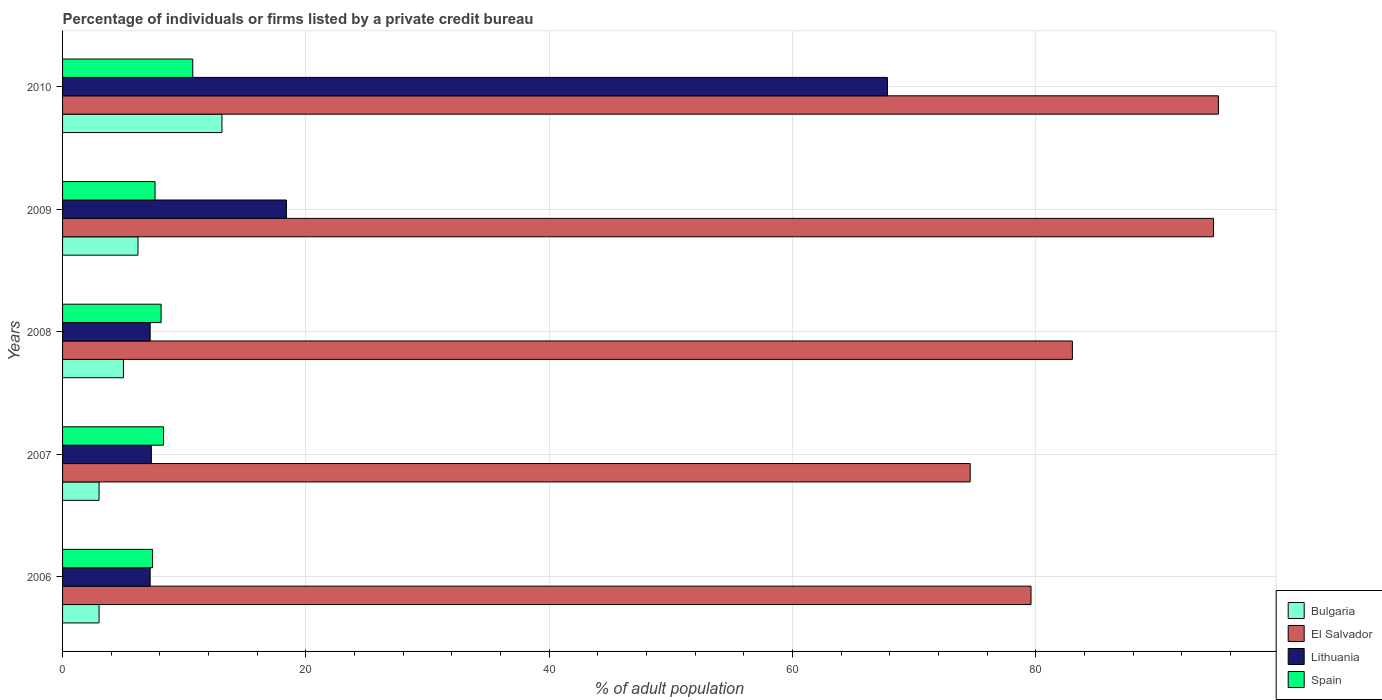How many groups of bars are there?
Offer a very short reply. 5. Are the number of bars per tick equal to the number of legend labels?
Ensure brevity in your answer.  Yes. Are the number of bars on each tick of the Y-axis equal?
Keep it short and to the point. Yes. What is the label of the 3rd group of bars from the top?
Your answer should be very brief. 2008. What is the percentage of population listed by a private credit bureau in Spain in 2010?
Your answer should be compact. 10.7. Across all years, what is the maximum percentage of population listed by a private credit bureau in Spain?
Offer a terse response. 10.7. In which year was the percentage of population listed by a private credit bureau in Lithuania maximum?
Your response must be concise. 2010. In which year was the percentage of population listed by a private credit bureau in Lithuania minimum?
Provide a short and direct response. 2006. What is the total percentage of population listed by a private credit bureau in El Salvador in the graph?
Give a very brief answer. 426.8. What is the difference between the percentage of population listed by a private credit bureau in Bulgaria in 2008 and the percentage of population listed by a private credit bureau in El Salvador in 2007?
Give a very brief answer. -69.6. What is the average percentage of population listed by a private credit bureau in Bulgaria per year?
Keep it short and to the point. 6.06. In the year 2007, what is the difference between the percentage of population listed by a private credit bureau in Spain and percentage of population listed by a private credit bureau in Lithuania?
Provide a short and direct response. 1. What is the ratio of the percentage of population listed by a private credit bureau in Lithuania in 2009 to that in 2010?
Offer a terse response. 0.27. Is the percentage of population listed by a private credit bureau in Bulgaria in 2006 less than that in 2009?
Offer a terse response. Yes. What is the difference between the highest and the second highest percentage of population listed by a private credit bureau in El Salvador?
Provide a short and direct response. 0.4. What is the difference between the highest and the lowest percentage of population listed by a private credit bureau in El Salvador?
Provide a succinct answer. 20.4. How many bars are there?
Ensure brevity in your answer.  20. Does the graph contain any zero values?
Give a very brief answer. No. Does the graph contain grids?
Your response must be concise. Yes. How many legend labels are there?
Keep it short and to the point. 4. What is the title of the graph?
Provide a short and direct response. Percentage of individuals or firms listed by a private credit bureau. Does "Korea (Democratic)" appear as one of the legend labels in the graph?
Keep it short and to the point. No. What is the label or title of the X-axis?
Provide a short and direct response. % of adult population. What is the label or title of the Y-axis?
Make the answer very short. Years. What is the % of adult population of Bulgaria in 2006?
Your answer should be very brief. 3. What is the % of adult population of El Salvador in 2006?
Provide a short and direct response. 79.6. What is the % of adult population in Lithuania in 2006?
Your response must be concise. 7.2. What is the % of adult population of Bulgaria in 2007?
Offer a terse response. 3. What is the % of adult population of El Salvador in 2007?
Provide a short and direct response. 74.6. What is the % of adult population in Spain in 2008?
Give a very brief answer. 8.1. What is the % of adult population of El Salvador in 2009?
Ensure brevity in your answer.  94.6. What is the % of adult population of Spain in 2009?
Ensure brevity in your answer.  7.6. What is the % of adult population of Bulgaria in 2010?
Your response must be concise. 13.1. What is the % of adult population of El Salvador in 2010?
Ensure brevity in your answer.  95. What is the % of adult population in Lithuania in 2010?
Offer a terse response. 67.8. Across all years, what is the maximum % of adult population in El Salvador?
Keep it short and to the point. 95. Across all years, what is the maximum % of adult population in Lithuania?
Provide a succinct answer. 67.8. Across all years, what is the minimum % of adult population of El Salvador?
Make the answer very short. 74.6. What is the total % of adult population in Bulgaria in the graph?
Make the answer very short. 30.3. What is the total % of adult population of El Salvador in the graph?
Your response must be concise. 426.8. What is the total % of adult population of Lithuania in the graph?
Your response must be concise. 107.9. What is the total % of adult population of Spain in the graph?
Your response must be concise. 42.1. What is the difference between the % of adult population of Bulgaria in 2006 and that in 2007?
Provide a short and direct response. 0. What is the difference between the % of adult population in El Salvador in 2006 and that in 2007?
Your answer should be very brief. 5. What is the difference between the % of adult population in El Salvador in 2006 and that in 2008?
Make the answer very short. -3.4. What is the difference between the % of adult population of Lithuania in 2006 and that in 2008?
Make the answer very short. 0. What is the difference between the % of adult population of Bulgaria in 2006 and that in 2009?
Make the answer very short. -3.2. What is the difference between the % of adult population of El Salvador in 2006 and that in 2009?
Provide a short and direct response. -15. What is the difference between the % of adult population in El Salvador in 2006 and that in 2010?
Make the answer very short. -15.4. What is the difference between the % of adult population in Lithuania in 2006 and that in 2010?
Ensure brevity in your answer.  -60.6. What is the difference between the % of adult population in Bulgaria in 2007 and that in 2008?
Your response must be concise. -2. What is the difference between the % of adult population of El Salvador in 2007 and that in 2009?
Your answer should be compact. -20. What is the difference between the % of adult population of El Salvador in 2007 and that in 2010?
Offer a very short reply. -20.4. What is the difference between the % of adult population of Lithuania in 2007 and that in 2010?
Your response must be concise. -60.5. What is the difference between the % of adult population of Bulgaria in 2008 and that in 2009?
Your response must be concise. -1.2. What is the difference between the % of adult population in Lithuania in 2008 and that in 2009?
Offer a very short reply. -11.2. What is the difference between the % of adult population of Lithuania in 2008 and that in 2010?
Your response must be concise. -60.6. What is the difference between the % of adult population in Bulgaria in 2009 and that in 2010?
Your answer should be very brief. -6.9. What is the difference between the % of adult population of El Salvador in 2009 and that in 2010?
Give a very brief answer. -0.4. What is the difference between the % of adult population of Lithuania in 2009 and that in 2010?
Your answer should be very brief. -49.4. What is the difference between the % of adult population of Bulgaria in 2006 and the % of adult population of El Salvador in 2007?
Your answer should be very brief. -71.6. What is the difference between the % of adult population in Bulgaria in 2006 and the % of adult population in Spain in 2007?
Ensure brevity in your answer.  -5.3. What is the difference between the % of adult population in El Salvador in 2006 and the % of adult population in Lithuania in 2007?
Give a very brief answer. 72.3. What is the difference between the % of adult population of El Salvador in 2006 and the % of adult population of Spain in 2007?
Give a very brief answer. 71.3. What is the difference between the % of adult population in Lithuania in 2006 and the % of adult population in Spain in 2007?
Offer a very short reply. -1.1. What is the difference between the % of adult population of Bulgaria in 2006 and the % of adult population of El Salvador in 2008?
Ensure brevity in your answer.  -80. What is the difference between the % of adult population in Bulgaria in 2006 and the % of adult population in Lithuania in 2008?
Provide a short and direct response. -4.2. What is the difference between the % of adult population of Bulgaria in 2006 and the % of adult population of Spain in 2008?
Keep it short and to the point. -5.1. What is the difference between the % of adult population in El Salvador in 2006 and the % of adult population in Lithuania in 2008?
Your answer should be compact. 72.4. What is the difference between the % of adult population in El Salvador in 2006 and the % of adult population in Spain in 2008?
Your answer should be very brief. 71.5. What is the difference between the % of adult population of Bulgaria in 2006 and the % of adult population of El Salvador in 2009?
Offer a terse response. -91.6. What is the difference between the % of adult population in Bulgaria in 2006 and the % of adult population in Lithuania in 2009?
Your answer should be compact. -15.4. What is the difference between the % of adult population in El Salvador in 2006 and the % of adult population in Lithuania in 2009?
Ensure brevity in your answer.  61.2. What is the difference between the % of adult population of El Salvador in 2006 and the % of adult population of Spain in 2009?
Your response must be concise. 72. What is the difference between the % of adult population in Lithuania in 2006 and the % of adult population in Spain in 2009?
Your response must be concise. -0.4. What is the difference between the % of adult population in Bulgaria in 2006 and the % of adult population in El Salvador in 2010?
Give a very brief answer. -92. What is the difference between the % of adult population of Bulgaria in 2006 and the % of adult population of Lithuania in 2010?
Your response must be concise. -64.8. What is the difference between the % of adult population of El Salvador in 2006 and the % of adult population of Spain in 2010?
Keep it short and to the point. 68.9. What is the difference between the % of adult population in Lithuania in 2006 and the % of adult population in Spain in 2010?
Make the answer very short. -3.5. What is the difference between the % of adult population in Bulgaria in 2007 and the % of adult population in El Salvador in 2008?
Provide a short and direct response. -80. What is the difference between the % of adult population of El Salvador in 2007 and the % of adult population of Lithuania in 2008?
Ensure brevity in your answer.  67.4. What is the difference between the % of adult population of El Salvador in 2007 and the % of adult population of Spain in 2008?
Your answer should be very brief. 66.5. What is the difference between the % of adult population in Lithuania in 2007 and the % of adult population in Spain in 2008?
Your response must be concise. -0.8. What is the difference between the % of adult population of Bulgaria in 2007 and the % of adult population of El Salvador in 2009?
Your answer should be compact. -91.6. What is the difference between the % of adult population of Bulgaria in 2007 and the % of adult population of Lithuania in 2009?
Make the answer very short. -15.4. What is the difference between the % of adult population of Bulgaria in 2007 and the % of adult population of Spain in 2009?
Your response must be concise. -4.6. What is the difference between the % of adult population in El Salvador in 2007 and the % of adult population in Lithuania in 2009?
Offer a very short reply. 56.2. What is the difference between the % of adult population of Bulgaria in 2007 and the % of adult population of El Salvador in 2010?
Give a very brief answer. -92. What is the difference between the % of adult population of Bulgaria in 2007 and the % of adult population of Lithuania in 2010?
Provide a short and direct response. -64.8. What is the difference between the % of adult population in Bulgaria in 2007 and the % of adult population in Spain in 2010?
Offer a very short reply. -7.7. What is the difference between the % of adult population in El Salvador in 2007 and the % of adult population in Spain in 2010?
Make the answer very short. 63.9. What is the difference between the % of adult population of Bulgaria in 2008 and the % of adult population of El Salvador in 2009?
Provide a succinct answer. -89.6. What is the difference between the % of adult population of Bulgaria in 2008 and the % of adult population of Lithuania in 2009?
Ensure brevity in your answer.  -13.4. What is the difference between the % of adult population in El Salvador in 2008 and the % of adult population in Lithuania in 2009?
Keep it short and to the point. 64.6. What is the difference between the % of adult population of El Salvador in 2008 and the % of adult population of Spain in 2009?
Give a very brief answer. 75.4. What is the difference between the % of adult population of Bulgaria in 2008 and the % of adult population of El Salvador in 2010?
Make the answer very short. -90. What is the difference between the % of adult population in Bulgaria in 2008 and the % of adult population in Lithuania in 2010?
Your response must be concise. -62.8. What is the difference between the % of adult population in Bulgaria in 2008 and the % of adult population in Spain in 2010?
Give a very brief answer. -5.7. What is the difference between the % of adult population in El Salvador in 2008 and the % of adult population in Lithuania in 2010?
Provide a succinct answer. 15.2. What is the difference between the % of adult population of El Salvador in 2008 and the % of adult population of Spain in 2010?
Give a very brief answer. 72.3. What is the difference between the % of adult population in Lithuania in 2008 and the % of adult population in Spain in 2010?
Offer a terse response. -3.5. What is the difference between the % of adult population in Bulgaria in 2009 and the % of adult population in El Salvador in 2010?
Keep it short and to the point. -88.8. What is the difference between the % of adult population in Bulgaria in 2009 and the % of adult population in Lithuania in 2010?
Keep it short and to the point. -61.6. What is the difference between the % of adult population in Bulgaria in 2009 and the % of adult population in Spain in 2010?
Give a very brief answer. -4.5. What is the difference between the % of adult population in El Salvador in 2009 and the % of adult population in Lithuania in 2010?
Give a very brief answer. 26.8. What is the difference between the % of adult population of El Salvador in 2009 and the % of adult population of Spain in 2010?
Your answer should be very brief. 83.9. What is the difference between the % of adult population in Lithuania in 2009 and the % of adult population in Spain in 2010?
Make the answer very short. 7.7. What is the average % of adult population of Bulgaria per year?
Your answer should be compact. 6.06. What is the average % of adult population of El Salvador per year?
Provide a short and direct response. 85.36. What is the average % of adult population in Lithuania per year?
Your answer should be compact. 21.58. What is the average % of adult population of Spain per year?
Your answer should be very brief. 8.42. In the year 2006, what is the difference between the % of adult population in Bulgaria and % of adult population in El Salvador?
Offer a terse response. -76.6. In the year 2006, what is the difference between the % of adult population of Bulgaria and % of adult population of Spain?
Make the answer very short. -4.4. In the year 2006, what is the difference between the % of adult population in El Salvador and % of adult population in Lithuania?
Offer a terse response. 72.4. In the year 2006, what is the difference between the % of adult population of El Salvador and % of adult population of Spain?
Your answer should be very brief. 72.2. In the year 2006, what is the difference between the % of adult population of Lithuania and % of adult population of Spain?
Give a very brief answer. -0.2. In the year 2007, what is the difference between the % of adult population of Bulgaria and % of adult population of El Salvador?
Make the answer very short. -71.6. In the year 2007, what is the difference between the % of adult population in Bulgaria and % of adult population in Lithuania?
Make the answer very short. -4.3. In the year 2007, what is the difference between the % of adult population of Bulgaria and % of adult population of Spain?
Provide a short and direct response. -5.3. In the year 2007, what is the difference between the % of adult population in El Salvador and % of adult population in Lithuania?
Offer a very short reply. 67.3. In the year 2007, what is the difference between the % of adult population of El Salvador and % of adult population of Spain?
Offer a very short reply. 66.3. In the year 2007, what is the difference between the % of adult population of Lithuania and % of adult population of Spain?
Keep it short and to the point. -1. In the year 2008, what is the difference between the % of adult population in Bulgaria and % of adult population in El Salvador?
Provide a succinct answer. -78. In the year 2008, what is the difference between the % of adult population in Bulgaria and % of adult population in Lithuania?
Ensure brevity in your answer.  -2.2. In the year 2008, what is the difference between the % of adult population of El Salvador and % of adult population of Lithuania?
Your answer should be very brief. 75.8. In the year 2008, what is the difference between the % of adult population of El Salvador and % of adult population of Spain?
Ensure brevity in your answer.  74.9. In the year 2009, what is the difference between the % of adult population in Bulgaria and % of adult population in El Salvador?
Ensure brevity in your answer.  -88.4. In the year 2009, what is the difference between the % of adult population in Bulgaria and % of adult population in Spain?
Provide a short and direct response. -1.4. In the year 2009, what is the difference between the % of adult population in El Salvador and % of adult population in Lithuania?
Keep it short and to the point. 76.2. In the year 2009, what is the difference between the % of adult population of Lithuania and % of adult population of Spain?
Give a very brief answer. 10.8. In the year 2010, what is the difference between the % of adult population of Bulgaria and % of adult population of El Salvador?
Ensure brevity in your answer.  -81.9. In the year 2010, what is the difference between the % of adult population in Bulgaria and % of adult population in Lithuania?
Make the answer very short. -54.7. In the year 2010, what is the difference between the % of adult population of El Salvador and % of adult population of Lithuania?
Provide a short and direct response. 27.2. In the year 2010, what is the difference between the % of adult population of El Salvador and % of adult population of Spain?
Provide a succinct answer. 84.3. In the year 2010, what is the difference between the % of adult population in Lithuania and % of adult population in Spain?
Ensure brevity in your answer.  57.1. What is the ratio of the % of adult population of El Salvador in 2006 to that in 2007?
Give a very brief answer. 1.07. What is the ratio of the % of adult population of Lithuania in 2006 to that in 2007?
Your answer should be very brief. 0.99. What is the ratio of the % of adult population of Spain in 2006 to that in 2007?
Provide a short and direct response. 0.89. What is the ratio of the % of adult population of Bulgaria in 2006 to that in 2008?
Keep it short and to the point. 0.6. What is the ratio of the % of adult population of Spain in 2006 to that in 2008?
Provide a short and direct response. 0.91. What is the ratio of the % of adult population of Bulgaria in 2006 to that in 2009?
Provide a succinct answer. 0.48. What is the ratio of the % of adult population of El Salvador in 2006 to that in 2009?
Your answer should be compact. 0.84. What is the ratio of the % of adult population of Lithuania in 2006 to that in 2009?
Offer a terse response. 0.39. What is the ratio of the % of adult population of Spain in 2006 to that in 2009?
Give a very brief answer. 0.97. What is the ratio of the % of adult population of Bulgaria in 2006 to that in 2010?
Provide a succinct answer. 0.23. What is the ratio of the % of adult population of El Salvador in 2006 to that in 2010?
Ensure brevity in your answer.  0.84. What is the ratio of the % of adult population of Lithuania in 2006 to that in 2010?
Provide a short and direct response. 0.11. What is the ratio of the % of adult population of Spain in 2006 to that in 2010?
Offer a terse response. 0.69. What is the ratio of the % of adult population in El Salvador in 2007 to that in 2008?
Make the answer very short. 0.9. What is the ratio of the % of adult population of Lithuania in 2007 to that in 2008?
Ensure brevity in your answer.  1.01. What is the ratio of the % of adult population in Spain in 2007 to that in 2008?
Offer a terse response. 1.02. What is the ratio of the % of adult population of Bulgaria in 2007 to that in 2009?
Provide a succinct answer. 0.48. What is the ratio of the % of adult population of El Salvador in 2007 to that in 2009?
Provide a short and direct response. 0.79. What is the ratio of the % of adult population of Lithuania in 2007 to that in 2009?
Make the answer very short. 0.4. What is the ratio of the % of adult population of Spain in 2007 to that in 2009?
Make the answer very short. 1.09. What is the ratio of the % of adult population in Bulgaria in 2007 to that in 2010?
Your response must be concise. 0.23. What is the ratio of the % of adult population of El Salvador in 2007 to that in 2010?
Ensure brevity in your answer.  0.79. What is the ratio of the % of adult population of Lithuania in 2007 to that in 2010?
Keep it short and to the point. 0.11. What is the ratio of the % of adult population in Spain in 2007 to that in 2010?
Provide a succinct answer. 0.78. What is the ratio of the % of adult population in Bulgaria in 2008 to that in 2009?
Offer a terse response. 0.81. What is the ratio of the % of adult population in El Salvador in 2008 to that in 2009?
Offer a very short reply. 0.88. What is the ratio of the % of adult population of Lithuania in 2008 to that in 2009?
Your response must be concise. 0.39. What is the ratio of the % of adult population of Spain in 2008 to that in 2009?
Provide a short and direct response. 1.07. What is the ratio of the % of adult population of Bulgaria in 2008 to that in 2010?
Your answer should be compact. 0.38. What is the ratio of the % of adult population in El Salvador in 2008 to that in 2010?
Keep it short and to the point. 0.87. What is the ratio of the % of adult population of Lithuania in 2008 to that in 2010?
Keep it short and to the point. 0.11. What is the ratio of the % of adult population in Spain in 2008 to that in 2010?
Ensure brevity in your answer.  0.76. What is the ratio of the % of adult population of Bulgaria in 2009 to that in 2010?
Give a very brief answer. 0.47. What is the ratio of the % of adult population in Lithuania in 2009 to that in 2010?
Provide a short and direct response. 0.27. What is the ratio of the % of adult population of Spain in 2009 to that in 2010?
Provide a short and direct response. 0.71. What is the difference between the highest and the second highest % of adult population of Bulgaria?
Your answer should be compact. 6.9. What is the difference between the highest and the second highest % of adult population in Lithuania?
Your answer should be compact. 49.4. What is the difference between the highest and the second highest % of adult population in Spain?
Provide a short and direct response. 2.4. What is the difference between the highest and the lowest % of adult population of Bulgaria?
Your answer should be compact. 10.1. What is the difference between the highest and the lowest % of adult population of El Salvador?
Offer a terse response. 20.4. What is the difference between the highest and the lowest % of adult population in Lithuania?
Make the answer very short. 60.6. 